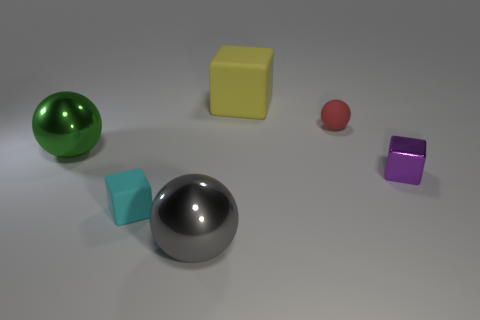What material is the big ball that is left of the cyan rubber object? The large ball positioned to the left of the cyan rubber object appears to be made of metal, exhibiting a smooth, reflective surface typical of metals such as steel or aluminum. 